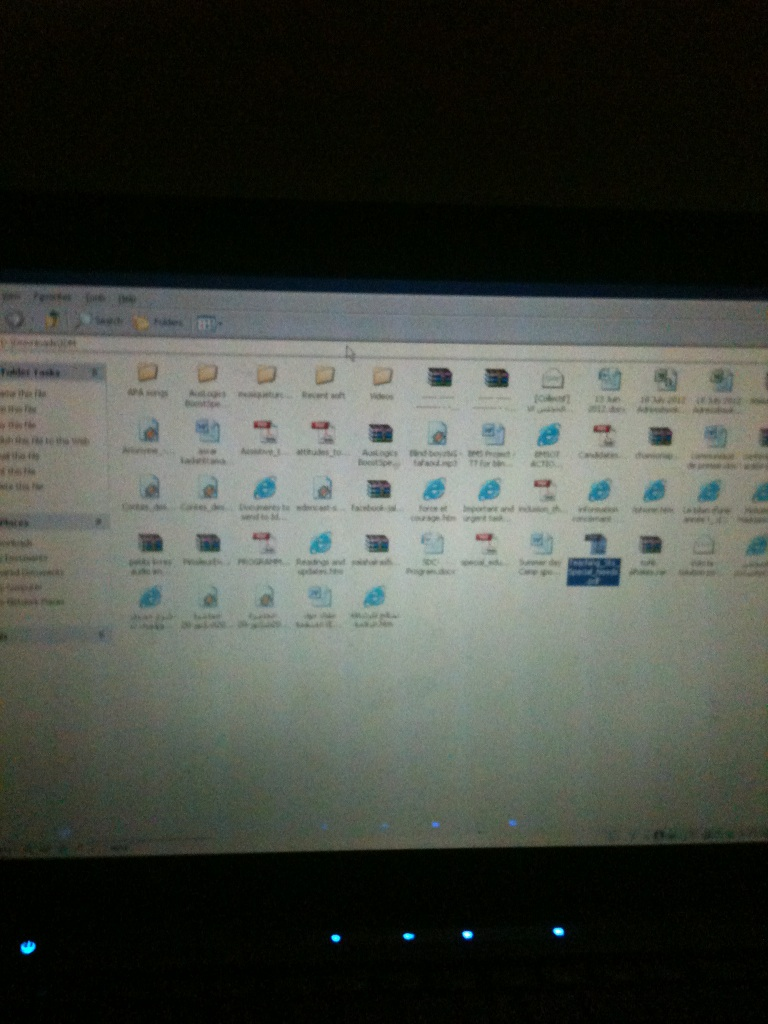What's this? This appears to be a screenshot of a computer folder containing various files and program icons. The icons are arranged in what might be default or custom categories, making it easier to navigate through frequently used or recently accessed files. 